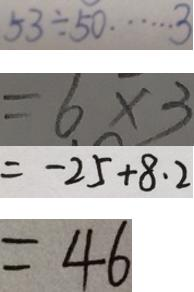<formula> <loc_0><loc_0><loc_500><loc_500>5 3 \div 5 0 \cdots 3 
 = 6 \times 3 
 = - 2 5 + 8 . 2 
 = 4 6</formula> 